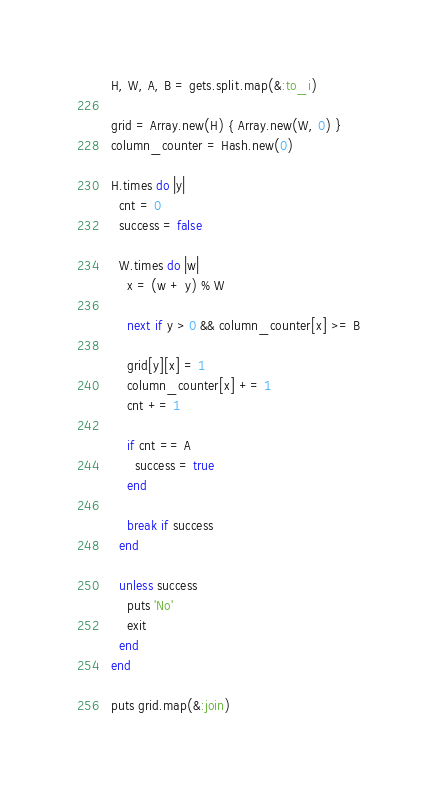<code> <loc_0><loc_0><loc_500><loc_500><_Ruby_>H, W, A, B = gets.split.map(&:to_i)

grid = Array.new(H) { Array.new(W, 0) }
column_counter = Hash.new(0)

H.times do |y|
  cnt = 0
  success = false

  W.times do |w|
    x = (w + y) % W

    next if y > 0 && column_counter[x] >= B

    grid[y][x] = 1
    column_counter[x] += 1
    cnt += 1

    if cnt == A
      success = true
    end

    break if success
  end

  unless success
    puts 'No'
    exit
  end
end

puts grid.map(&:join)
</code> 